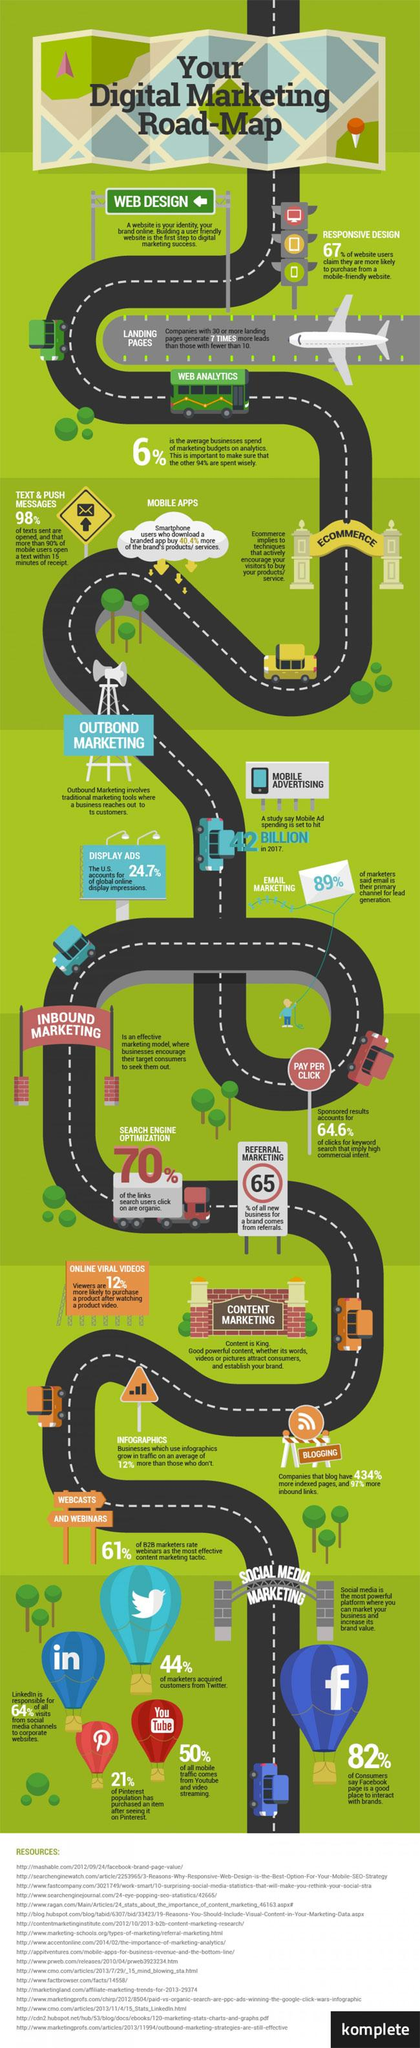Mention a couple of crucial points in this snapshot. Content marketing falls under the category of inbound marketing. It is widely believed that Facebook is the most commonly used social media tool for social media marketing, surpassing other platforms such as Twitter, LinkedIn, Pinterest, and YouTube. There are three types of marketing: outbound, inbound, and social media. Email marketing is a part of the category of marketing known as outbound marketing. 